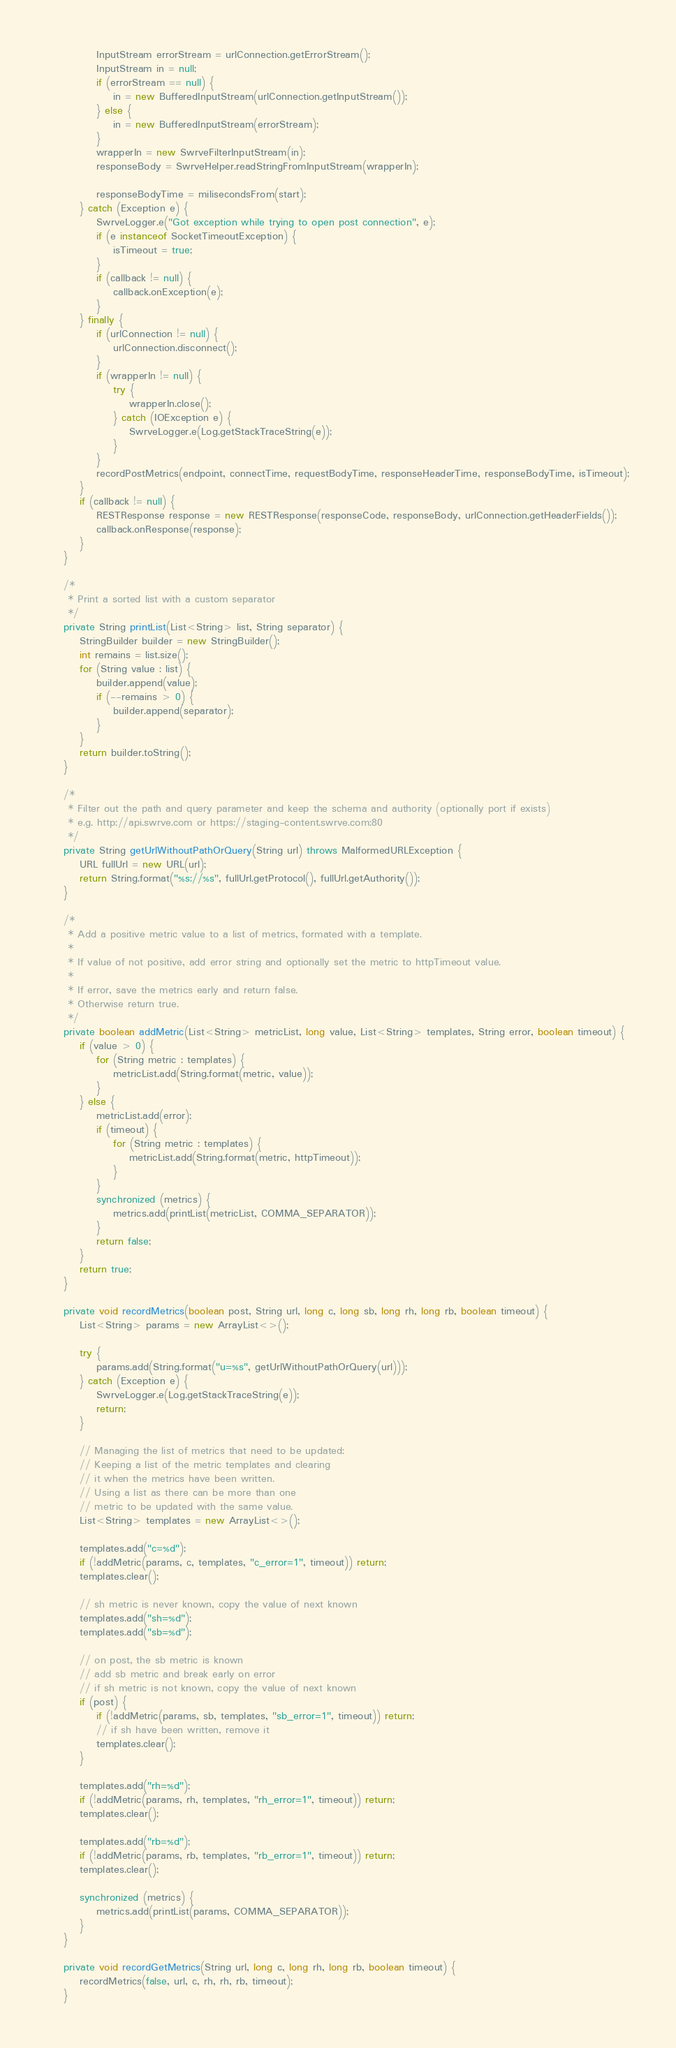Convert code to text. <code><loc_0><loc_0><loc_500><loc_500><_Java_>            InputStream errorStream = urlConnection.getErrorStream();
            InputStream in = null;
            if (errorStream == null) {
                in = new BufferedInputStream(urlConnection.getInputStream());
            } else {
                in = new BufferedInputStream(errorStream);
            }
            wrapperIn = new SwrveFilterInputStream(in);
            responseBody = SwrveHelper.readStringFromInputStream(wrapperIn);

            responseBodyTime = milisecondsFrom(start);
        } catch (Exception e) {
            SwrveLogger.e("Got exception while trying to open post connection", e);
            if (e instanceof SocketTimeoutException) {
                isTimeout = true;
            }
            if (callback != null) {
                callback.onException(e);
            }
        } finally {
            if (urlConnection != null) {
                urlConnection.disconnect();
            }
            if (wrapperIn != null) {
                try {
                    wrapperIn.close();
                } catch (IOException e) {
                    SwrveLogger.e(Log.getStackTraceString(e));
                }
            }
            recordPostMetrics(endpoint, connectTime, requestBodyTime, responseHeaderTime, responseBodyTime, isTimeout);
        }
        if (callback != null) {
            RESTResponse response = new RESTResponse(responseCode, responseBody, urlConnection.getHeaderFields());
            callback.onResponse(response);
        }
    }

    /*
     * Print a sorted list with a custom separator
     */
    private String printList(List<String> list, String separator) {
        StringBuilder builder = new StringBuilder();
        int remains = list.size();
        for (String value : list) {
            builder.append(value);
            if (--remains > 0) {
                builder.append(separator);
            }
        }
        return builder.toString();
    }

    /*
     * Filter out the path and query parameter and keep the schema and authority (optionally port if exists)
     * e.g. http://api.swrve.com or https://staging-content.swrve.com:80
     */
    private String getUrlWithoutPathOrQuery(String url) throws MalformedURLException {
        URL fullUrl = new URL(url);
        return String.format("%s://%s", fullUrl.getProtocol(), fullUrl.getAuthority());
    }

    /*
     * Add a positive metric value to a list of metrics, formated with a template.
     *
     * If value of not positive, add error string and optionally set the metric to httpTimeout value.
     *
     * If error, save the metrics early and return false.
     * Otherwise return true.
     */
    private boolean addMetric(List<String> metricList, long value, List<String> templates, String error, boolean timeout) {
        if (value > 0) {
            for (String metric : templates) {
                metricList.add(String.format(metric, value));
            }
        } else {
            metricList.add(error);
            if (timeout) {
                for (String metric : templates) {
                    metricList.add(String.format(metric, httpTimeout));
                }
            }
            synchronized (metrics) {
                metrics.add(printList(metricList, COMMA_SEPARATOR));
            }
            return false;
        }
        return true;
    }

    private void recordMetrics(boolean post, String url, long c, long sb, long rh, long rb, boolean timeout) {
        List<String> params = new ArrayList<>();

        try {
            params.add(String.format("u=%s", getUrlWithoutPathOrQuery(url)));
        } catch (Exception e) {
            SwrveLogger.e(Log.getStackTraceString(e));
            return;
        }

        // Managing the list of metrics that need to be updated:
        // Keeping a list of the metric templates and clearing
        // it when the metrics have been written.
        // Using a list as there can be more than one
        // metric to be updated with the same value.
        List<String> templates = new ArrayList<>();

        templates.add("c=%d");
        if (!addMetric(params, c, templates, "c_error=1", timeout)) return;
        templates.clear();

        // sh metric is never known, copy the value of next known
        templates.add("sh=%d");
        templates.add("sb=%d");

        // on post, the sb metric is known
        // add sb metric and break early on error
        // if sh metric is not known, copy the value of next known
        if (post) {
            if (!addMetric(params, sb, templates, "sb_error=1", timeout)) return;
            // if sh have been written, remove it
            templates.clear();
        }

        templates.add("rh=%d");
        if (!addMetric(params, rh, templates, "rh_error=1", timeout)) return;
        templates.clear();

        templates.add("rb=%d");
        if (!addMetric(params, rb, templates, "rb_error=1", timeout)) return;
        templates.clear();

        synchronized (metrics) {
            metrics.add(printList(params, COMMA_SEPARATOR));
        }
    }

    private void recordGetMetrics(String url, long c, long rh, long rb, boolean timeout) {
        recordMetrics(false, url, c, rh, rh, rb, timeout);
    }
</code> 